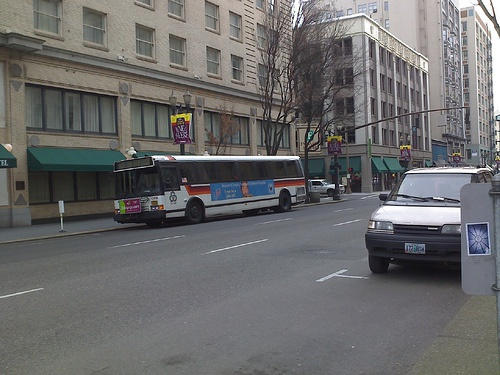Describe the objects in this image and their specific colors. I can see bus in gray, black, and blue tones, truck in gray, black, darkgray, and lavender tones, truck in gray, black, darkgray, and lightgray tones, traffic light in gray and black tones, and traffic light in gray and black tones in this image. 